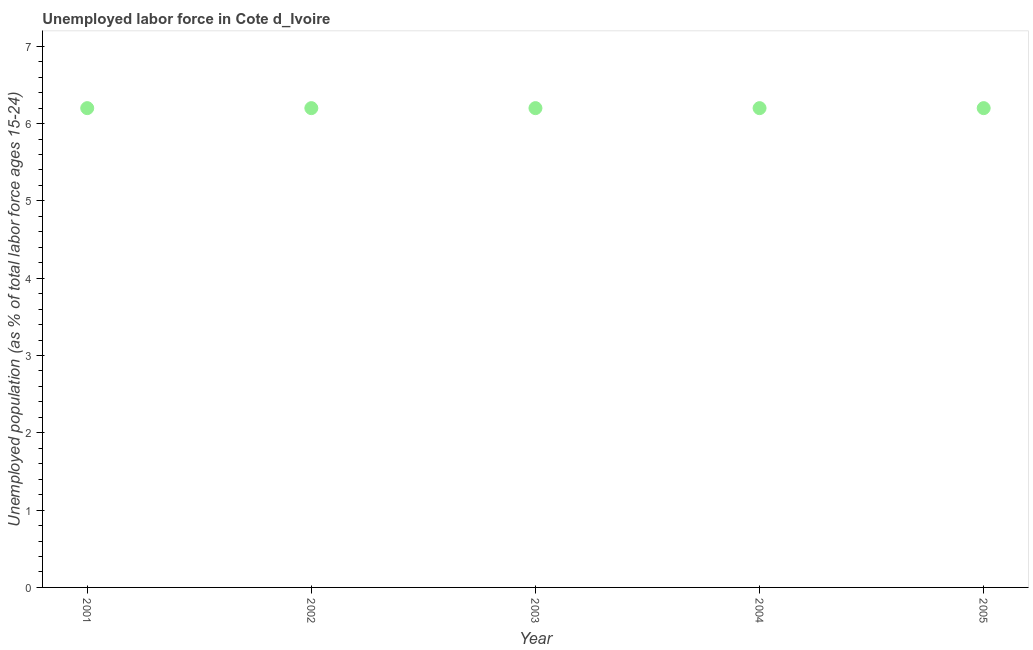What is the total unemployed youth population in 2005?
Keep it short and to the point. 6.2. Across all years, what is the maximum total unemployed youth population?
Offer a terse response. 6.2. Across all years, what is the minimum total unemployed youth population?
Give a very brief answer. 6.2. In which year was the total unemployed youth population maximum?
Provide a short and direct response. 2001. In which year was the total unemployed youth population minimum?
Keep it short and to the point. 2001. What is the sum of the total unemployed youth population?
Offer a very short reply. 31. What is the difference between the total unemployed youth population in 2001 and 2005?
Provide a succinct answer. 0. What is the average total unemployed youth population per year?
Keep it short and to the point. 6.2. What is the median total unemployed youth population?
Make the answer very short. 6.2. Do a majority of the years between 2005 and 2001 (inclusive) have total unemployed youth population greater than 1.2 %?
Your response must be concise. Yes. Is the total unemployed youth population in 2002 less than that in 2003?
Your answer should be very brief. No. Is the sum of the total unemployed youth population in 2001 and 2002 greater than the maximum total unemployed youth population across all years?
Provide a short and direct response. Yes. What is the difference between the highest and the lowest total unemployed youth population?
Your answer should be compact. 0. In how many years, is the total unemployed youth population greater than the average total unemployed youth population taken over all years?
Give a very brief answer. 0. How many years are there in the graph?
Give a very brief answer. 5. Does the graph contain any zero values?
Offer a terse response. No. Does the graph contain grids?
Provide a succinct answer. No. What is the title of the graph?
Provide a short and direct response. Unemployed labor force in Cote d_Ivoire. What is the label or title of the X-axis?
Your response must be concise. Year. What is the label or title of the Y-axis?
Ensure brevity in your answer.  Unemployed population (as % of total labor force ages 15-24). What is the Unemployed population (as % of total labor force ages 15-24) in 2001?
Keep it short and to the point. 6.2. What is the Unemployed population (as % of total labor force ages 15-24) in 2002?
Provide a succinct answer. 6.2. What is the Unemployed population (as % of total labor force ages 15-24) in 2003?
Your response must be concise. 6.2. What is the Unemployed population (as % of total labor force ages 15-24) in 2004?
Keep it short and to the point. 6.2. What is the Unemployed population (as % of total labor force ages 15-24) in 2005?
Make the answer very short. 6.2. What is the difference between the Unemployed population (as % of total labor force ages 15-24) in 2001 and 2002?
Your answer should be very brief. 0. What is the difference between the Unemployed population (as % of total labor force ages 15-24) in 2001 and 2003?
Make the answer very short. 0. What is the difference between the Unemployed population (as % of total labor force ages 15-24) in 2001 and 2005?
Give a very brief answer. 0. What is the difference between the Unemployed population (as % of total labor force ages 15-24) in 2002 and 2003?
Your response must be concise. 0. What is the difference between the Unemployed population (as % of total labor force ages 15-24) in 2002 and 2004?
Ensure brevity in your answer.  0. What is the difference between the Unemployed population (as % of total labor force ages 15-24) in 2002 and 2005?
Provide a short and direct response. 0. What is the ratio of the Unemployed population (as % of total labor force ages 15-24) in 2001 to that in 2002?
Your answer should be very brief. 1. What is the ratio of the Unemployed population (as % of total labor force ages 15-24) in 2002 to that in 2003?
Your answer should be very brief. 1. What is the ratio of the Unemployed population (as % of total labor force ages 15-24) in 2003 to that in 2004?
Make the answer very short. 1. What is the ratio of the Unemployed population (as % of total labor force ages 15-24) in 2003 to that in 2005?
Give a very brief answer. 1. 